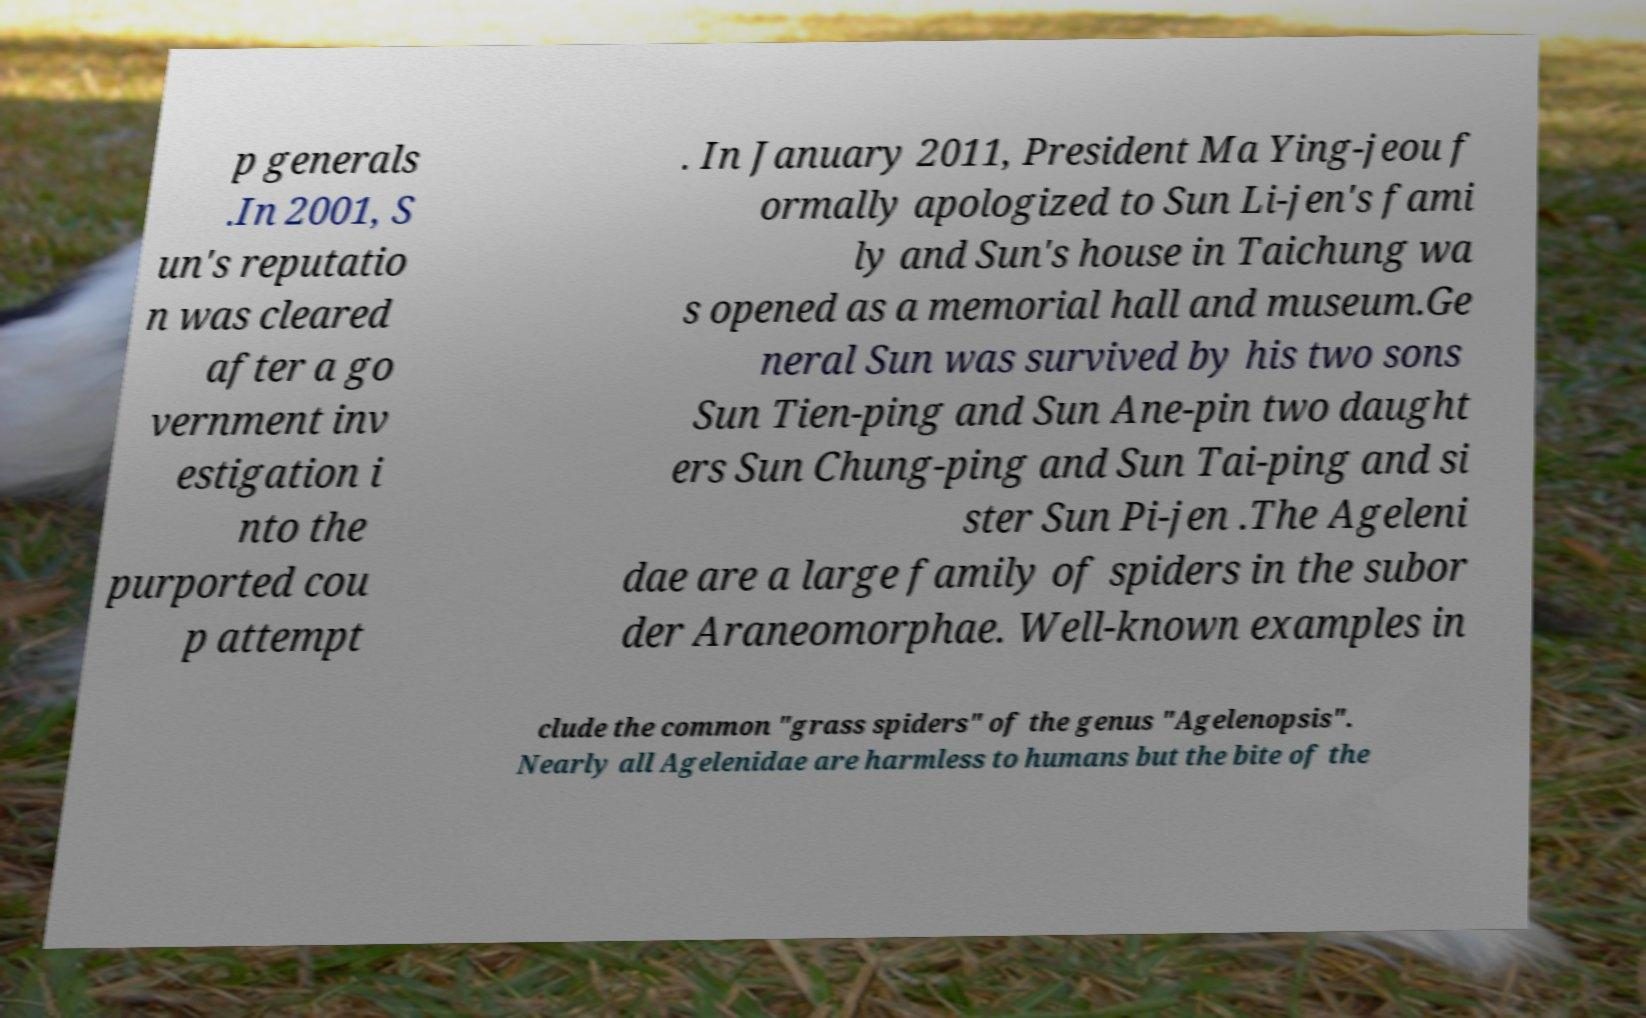Can you accurately transcribe the text from the provided image for me? p generals .In 2001, S un's reputatio n was cleared after a go vernment inv estigation i nto the purported cou p attempt . In January 2011, President Ma Ying-jeou f ormally apologized to Sun Li-jen's fami ly and Sun's house in Taichung wa s opened as a memorial hall and museum.Ge neral Sun was survived by his two sons Sun Tien-ping and Sun Ane-pin two daught ers Sun Chung-ping and Sun Tai-ping and si ster Sun Pi-jen .The Ageleni dae are a large family of spiders in the subor der Araneomorphae. Well-known examples in clude the common "grass spiders" of the genus "Agelenopsis". Nearly all Agelenidae are harmless to humans but the bite of the 